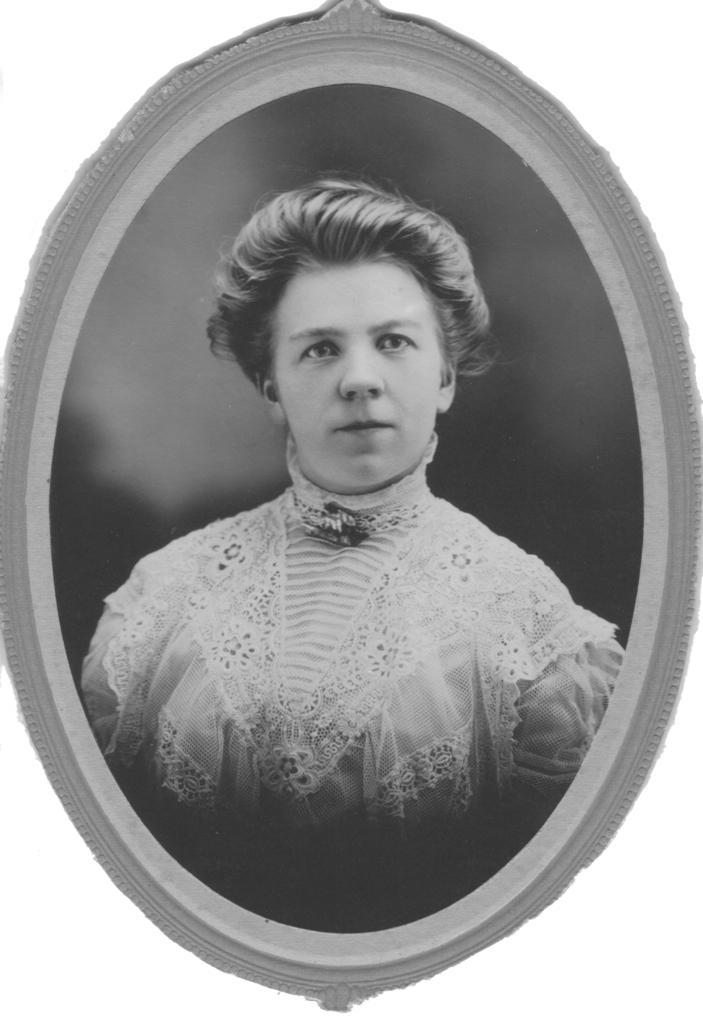Describe this image in one or two sentences. This is a black and white picture. This picture is mainly highlighted with a frame and we can see a person wearing a dress. 